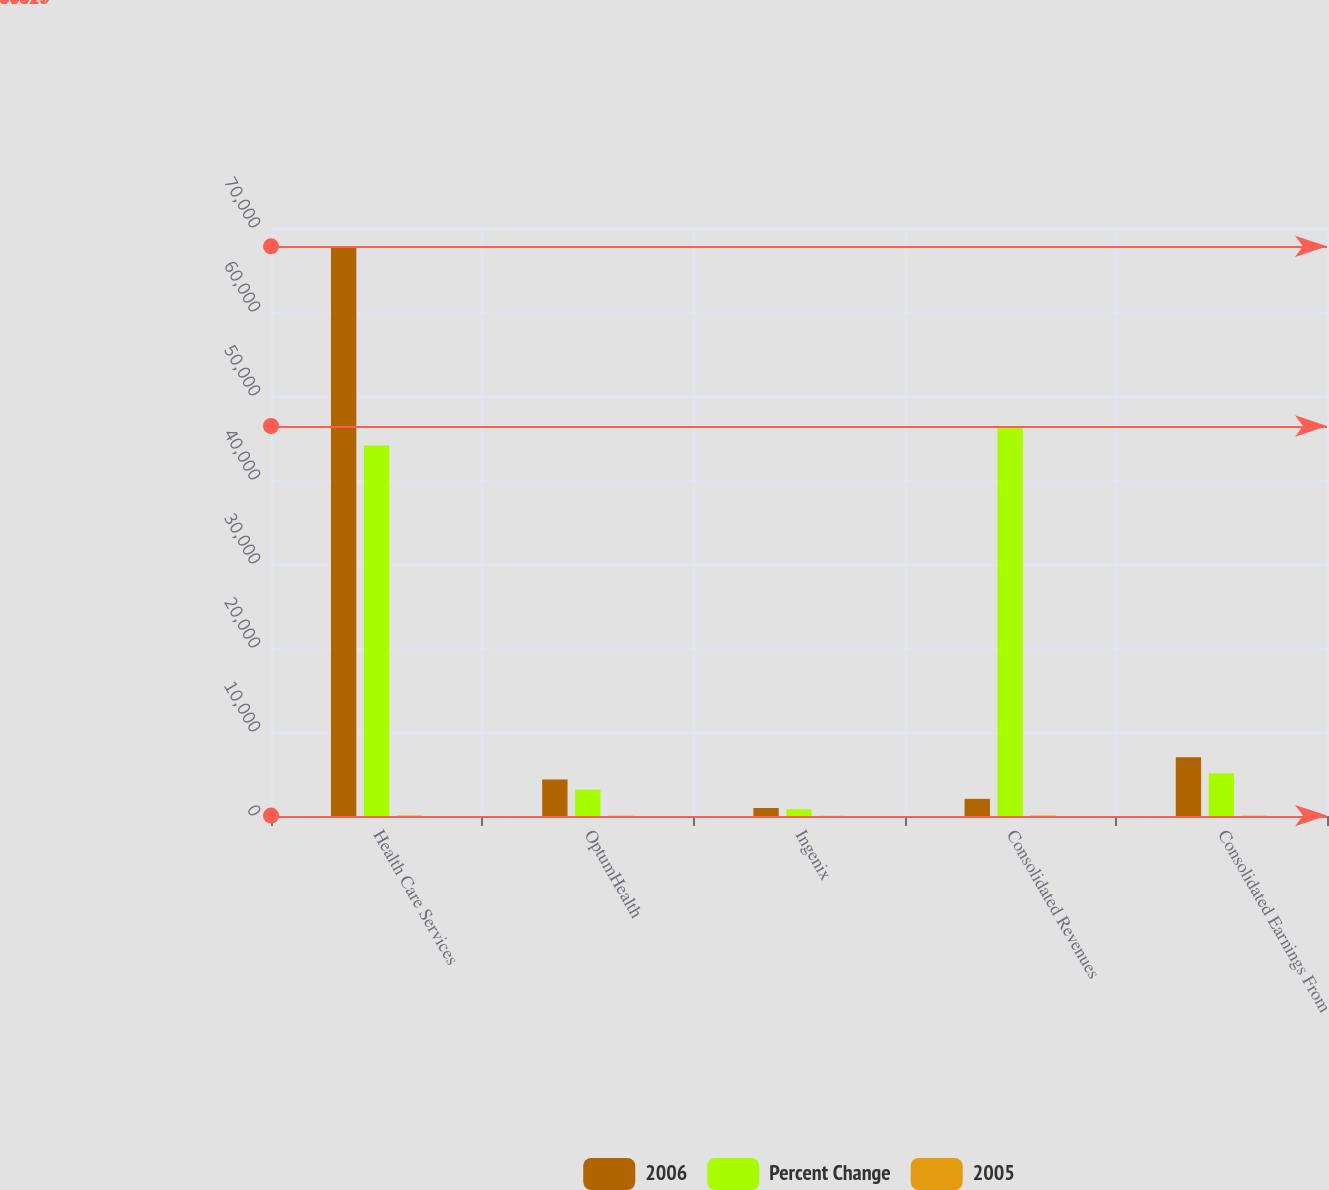Convert chart to OTSL. <chart><loc_0><loc_0><loc_500><loc_500><stacked_bar_chart><ecel><fcel>Health Care Services<fcel>OptumHealth<fcel>Ingenix<fcel>Consolidated Revenues<fcel>Consolidated Earnings From<nl><fcel>2006<fcel>67817<fcel>4342<fcel>956<fcel>2041.5<fcel>6984<nl><fcel>Percent Change<fcel>44119<fcel>3127<fcel>796<fcel>46425<fcel>5080<nl><fcel>2005<fcel>54<fcel>39<fcel>20<fcel>54<fcel>37<nl></chart> 